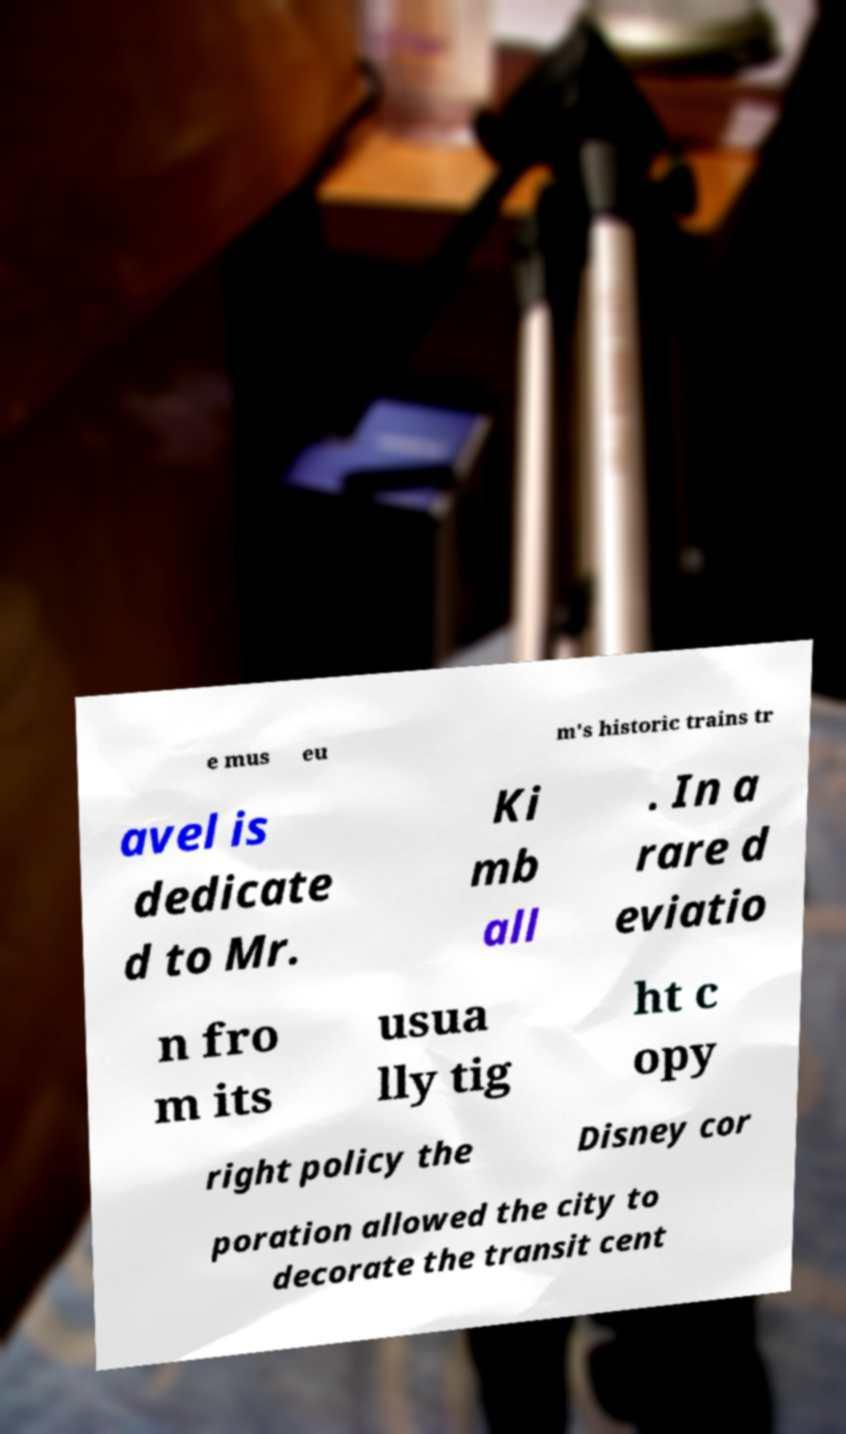Can you read and provide the text displayed in the image?This photo seems to have some interesting text. Can you extract and type it out for me? e mus eu m's historic trains tr avel is dedicate d to Mr. Ki mb all . In a rare d eviatio n fro m its usua lly tig ht c opy right policy the Disney cor poration allowed the city to decorate the transit cent 